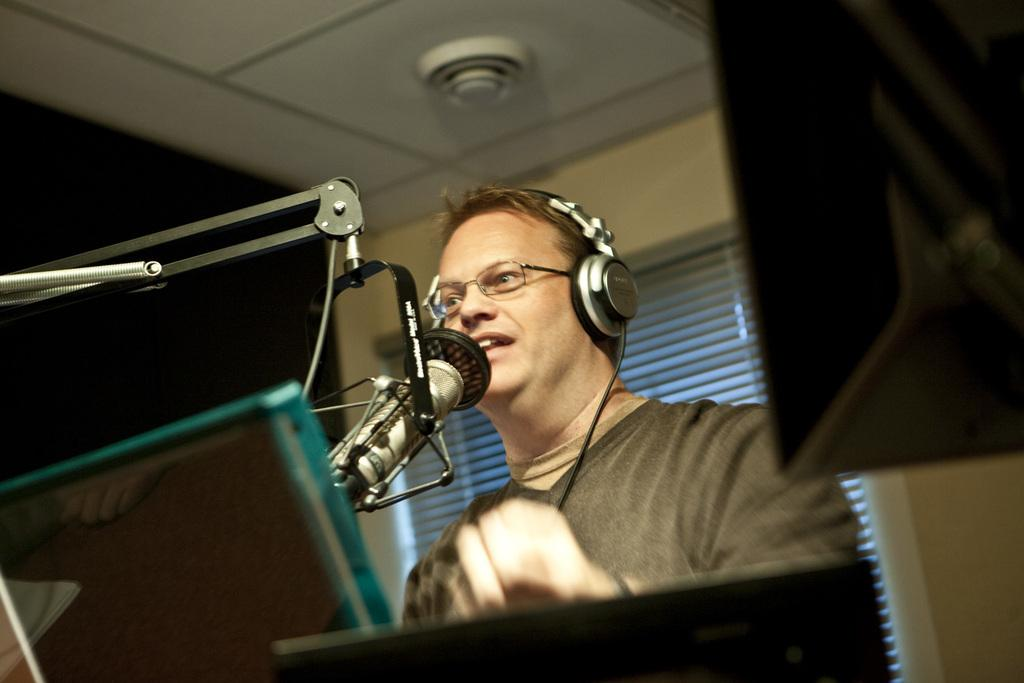What is the main subject of the image? There is a person in the image. What is the person wearing? The person is wearing a brown shirt. What is the person doing in the image? The person is singing. What is the person using while singing? The person is in front of a microphone. What can be seen in the background of the image? There is a sliding door and a cream-colored wall in the background of the image. What type of food is being sold at a low price in the image? There is no mention of food or prices in the image; it features a person singing in front of a microphone. 